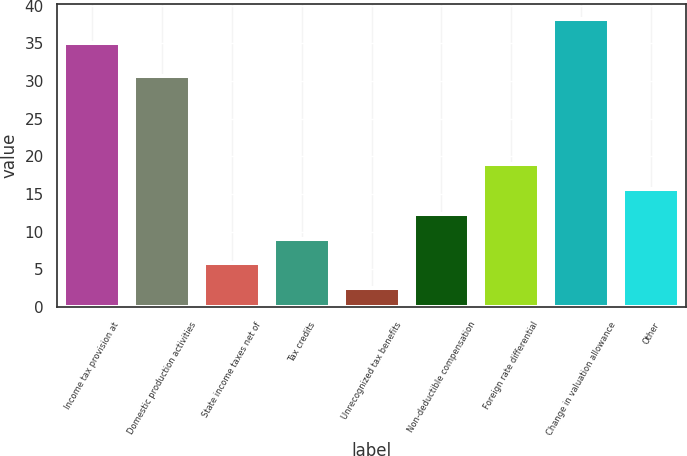Convert chart to OTSL. <chart><loc_0><loc_0><loc_500><loc_500><bar_chart><fcel>Income tax provision at<fcel>Domestic production activities<fcel>State income taxes net of<fcel>Tax credits<fcel>Unrecognized tax benefits<fcel>Non-deductible compensation<fcel>Foreign rate differential<fcel>Change in valuation allowance<fcel>Other<nl><fcel>35<fcel>30.6<fcel>5.79<fcel>9.08<fcel>2.5<fcel>12.37<fcel>18.95<fcel>38.29<fcel>15.66<nl></chart> 